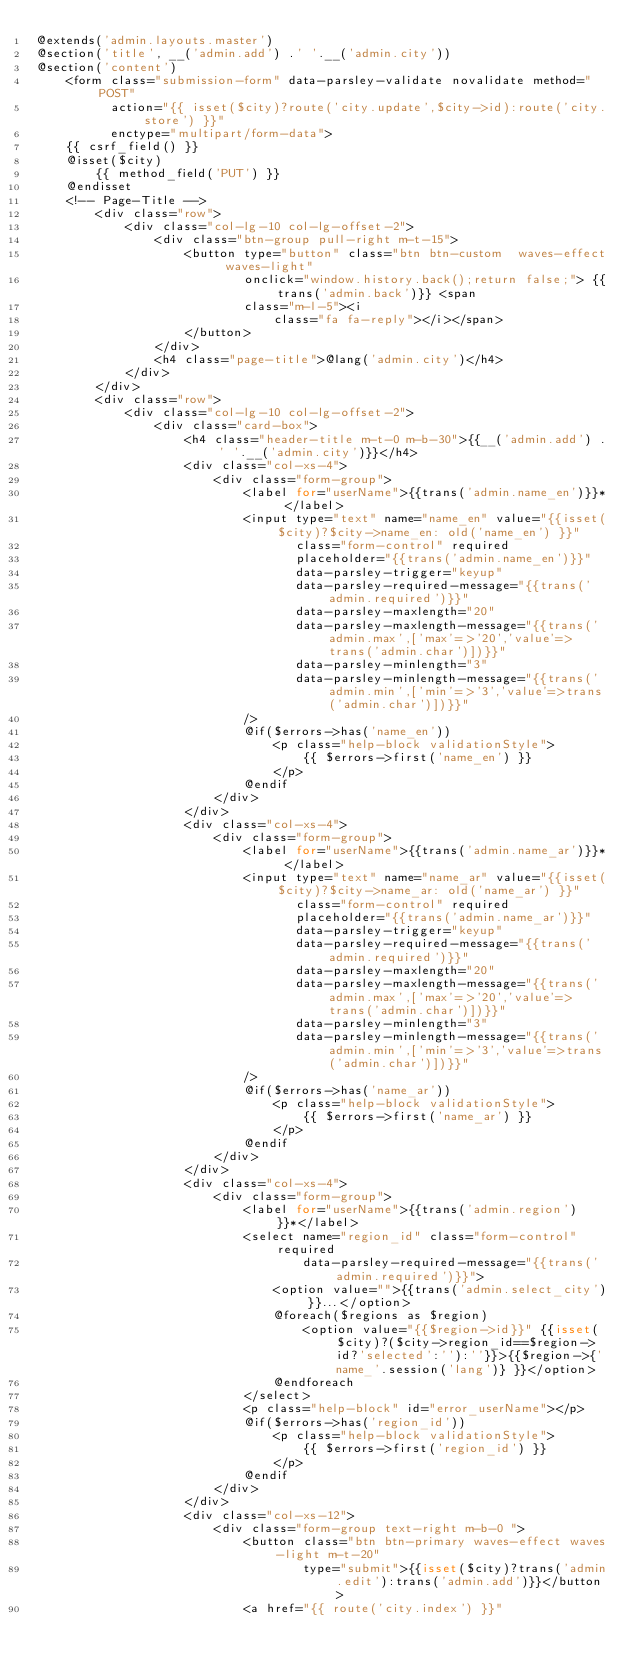Convert code to text. <code><loc_0><loc_0><loc_500><loc_500><_PHP_>@extends('admin.layouts.master')
@section('title', __('admin.add') .' '.__('admin.city'))
@section('content')
    <form class="submission-form" data-parsley-validate novalidate method="POST"
          action="{{ isset($city)?route('city.update',$city->id):route('city.store') }}"
          enctype="multipart/form-data">
    {{ csrf_field() }}
    @isset($city)
        {{ method_field('PUT') }}
    @endisset
    <!-- Page-Title -->
        <div class="row">
            <div class="col-lg-10 col-lg-offset-2">
                <div class="btn-group pull-right m-t-15">
                    <button type="button" class="btn btn-custom  waves-effect waves-light"
                            onclick="window.history.back();return false;"> {{trans('admin.back')}} <span
                            class="m-l-5"><i
                                class="fa fa-reply"></i></span>
                    </button>
                </div>
                <h4 class="page-title">@lang('admin.city')</h4>
            </div>
        </div>
        <div class="row">
            <div class="col-lg-10 col-lg-offset-2">
                <div class="card-box">
                    <h4 class="header-title m-t-0 m-b-30">{{__('admin.add') .' '.__('admin.city')}}</h4>
                    <div class="col-xs-4">
                        <div class="form-group">
                            <label for="userName">{{trans('admin.name_en')}}* </label>
                            <input type="text" name="name_en" value="{{isset($city)?$city->name_en: old('name_en') }}"
                                   class="form-control" required
                                   placeholder="{{trans('admin.name_en')}}"
                                   data-parsley-trigger="keyup"
                                   data-parsley-required-message="{{trans('admin.required')}}"
                                   data-parsley-maxlength="20"
                                   data-parsley-maxlength-message="{{trans('admin.max',['max'=>'20','value'=>trans('admin.char')])}}"
                                   data-parsley-minlength="3"
                                   data-parsley-minlength-message="{{trans('admin.min',['min'=>'3','value'=>trans('admin.char')])}}"
                            />
                            @if($errors->has('name_en'))
                                <p class="help-block validationStyle">
                                    {{ $errors->first('name_en') }}
                                </p>
                            @endif
                        </div>
                    </div>
                    <div class="col-xs-4">
                        <div class="form-group">
                            <label for="userName">{{trans('admin.name_ar')}}* </label>
                            <input type="text" name="name_ar" value="{{isset($city)?$city->name_ar: old('name_ar') }}"
                                   class="form-control" required
                                   placeholder="{{trans('admin.name_ar')}}"
                                   data-parsley-trigger="keyup"
                                   data-parsley-required-message="{{trans('admin.required')}}"
                                   data-parsley-maxlength="20"
                                   data-parsley-maxlength-message="{{trans('admin.max',['max'=>'20','value'=>trans('admin.char')])}}"
                                   data-parsley-minlength="3"
                                   data-parsley-minlength-message="{{trans('admin.min',['min'=>'3','value'=>trans('admin.char')])}}"
                            />
                            @if($errors->has('name_ar'))
                                <p class="help-block validationStyle">
                                    {{ $errors->first('name_ar') }}
                                </p>
                            @endif
                        </div>
                    </div>
                    <div class="col-xs-4">
                        <div class="form-group">
                            <label for="userName">{{trans('admin.region')}}*</label>
                            <select name="region_id" class="form-control" required
                                    data-parsley-required-message="{{trans('admin.required')}}">
                                <option value="">{{trans('admin.select_city')}}...</option>
                                @foreach($regions as $region)
                                    <option value="{{$region->id}}" {{isset($city)?($city->region_id==$region->id?'selected':''):''}}>{{$region->{'name_'.session('lang')} }}</option>
                                @endforeach
                            </select>
                            <p class="help-block" id="error_userName"></p>
                            @if($errors->has('region_id'))
                                <p class="help-block validationStyle">
                                    {{ $errors->first('region_id') }}
                                </p>
                            @endif
                        </div>
                    </div>
                    <div class="col-xs-12">
                        <div class="form-group text-right m-b-0 ">
                            <button class="btn btn-primary waves-effect waves-light m-t-20"
                                    type="submit">{{isset($city)?trans('admin.edit'):trans('admin.add')}}</button>
                            <a href="{{ route('city.index') }}"</code> 